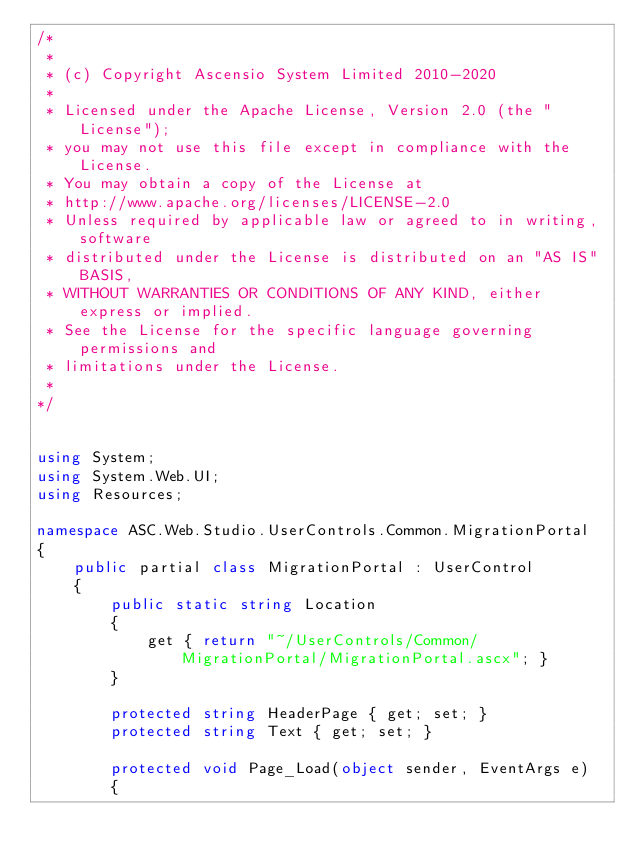Convert code to text. <code><loc_0><loc_0><loc_500><loc_500><_C#_>/*
 *
 * (c) Copyright Ascensio System Limited 2010-2020
 * 
 * Licensed under the Apache License, Version 2.0 (the "License");
 * you may not use this file except in compliance with the License.
 * You may obtain a copy of the License at
 * http://www.apache.org/licenses/LICENSE-2.0
 * Unless required by applicable law or agreed to in writing, software
 * distributed under the License is distributed on an "AS IS" BASIS,
 * WITHOUT WARRANTIES OR CONDITIONS OF ANY KIND, either express or implied.
 * See the License for the specific language governing permissions and
 * limitations under the License.
 *
*/


using System;
using System.Web.UI;
using Resources;

namespace ASC.Web.Studio.UserControls.Common.MigrationPortal
{
    public partial class MigrationPortal : UserControl
    {
        public static string Location
        {
            get { return "~/UserControls/Common/MigrationPortal/MigrationPortal.ascx"; }
        }

        protected string HeaderPage { get; set; }
        protected string Text { get; set; }

        protected void Page_Load(object sender, EventArgs e)
        {</code> 